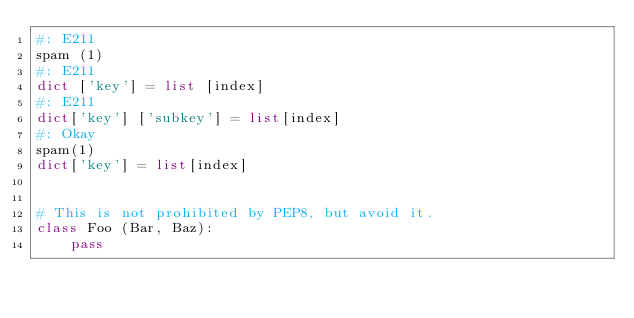Convert code to text. <code><loc_0><loc_0><loc_500><loc_500><_Python_>#: E211
spam (1)
#: E211
dict ['key'] = list [index]
#: E211
dict['key'] ['subkey'] = list[index]
#: Okay
spam(1)
dict['key'] = list[index]


# This is not prohibited by PEP8, but avoid it.
class Foo (Bar, Baz):
    pass
</code> 